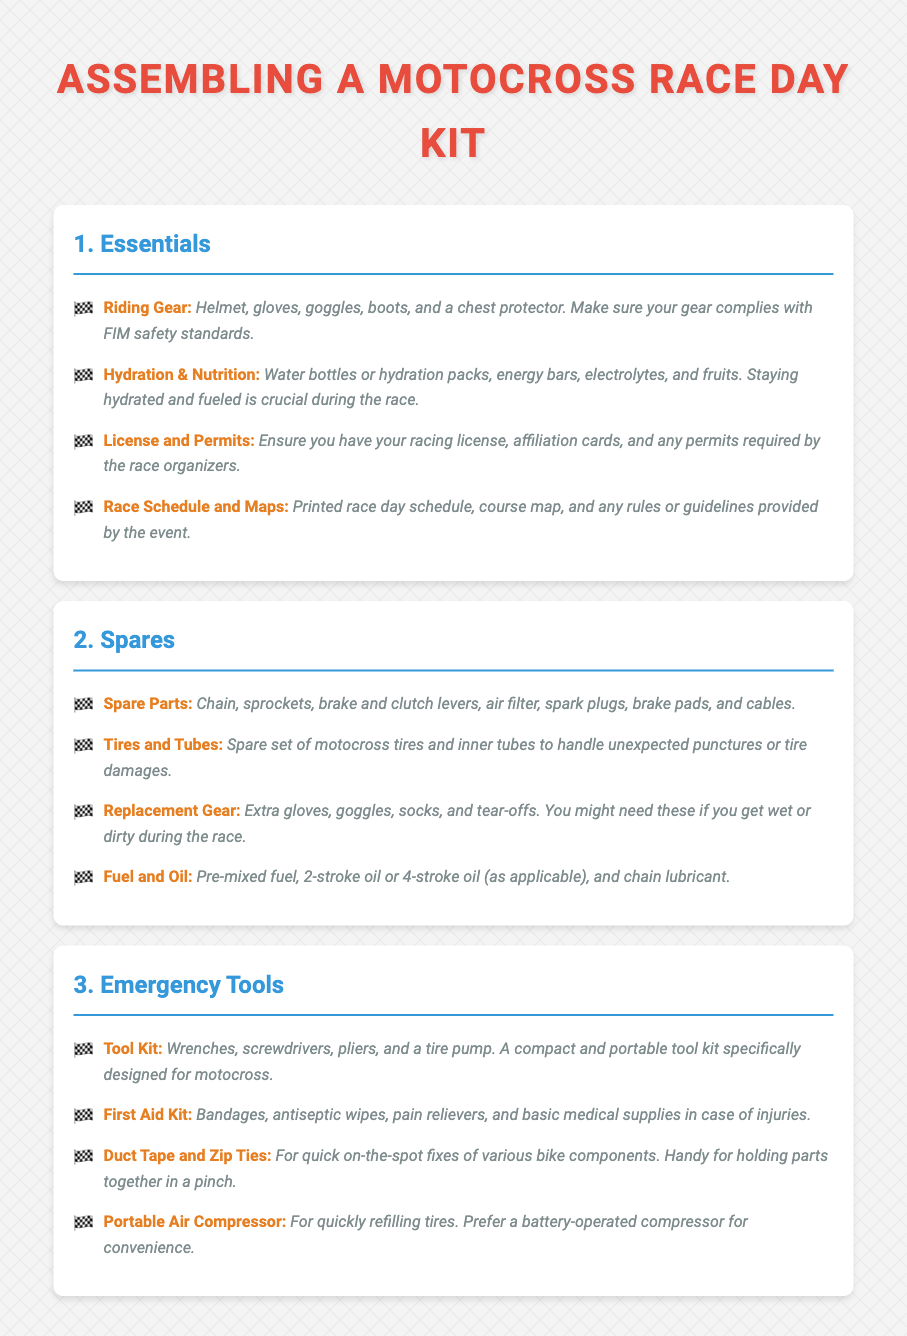What are the essentials for a motocross race day kit? The essentials are Riding Gear, Hydration & Nutrition, License and Permits, and Race Schedule and Maps.
Answer: Riding Gear, Hydration & Nutrition, License and Permits, Race Schedule and Maps How many spare parts are listed? The spare parts section lists eight specific items.
Answer: Eight What type of lubricant is mentioned for the fuel? The document specifies "chain lubricant" as part of the fuel and oil section.
Answer: Chain lubricant What is a recommended tool for quickly refilling tires? The document recommends a "Portable Air Compressor" for quickly refilling tires.
Answer: Portable Air Compressor Which safety equipment is included in the first aid kit? Bandages, antiseptic wipes, pain relievers, and basic medical supplies are listed in the first aid kit.
Answer: Bandages, antiseptic wipes, pain relievers, basic medical supplies Why is hydration important during the race? The document states that staying hydrated and fueled is crucial during the race.
Answer: Crucial What should you ensure regarding your racing license? You should ensure you have your racing license, affiliation cards, and any permits required by the race organizers.
Answer: Racing license, affiliation cards, permits What type of gloves are suggested in the replacement gear? The document mentions "extra gloves" as part of the replacement gear.
Answer: Extra gloves How should you carry your tools? The document specifies that a compact and portable tool kit should be used, designed specifically for motocross.
Answer: Compact and portable tool kit 